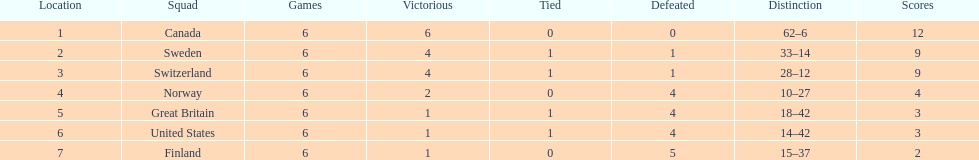During the 1951 world ice hockey championships, what was the difference between the first and last place teams for number of games won ? 5. 